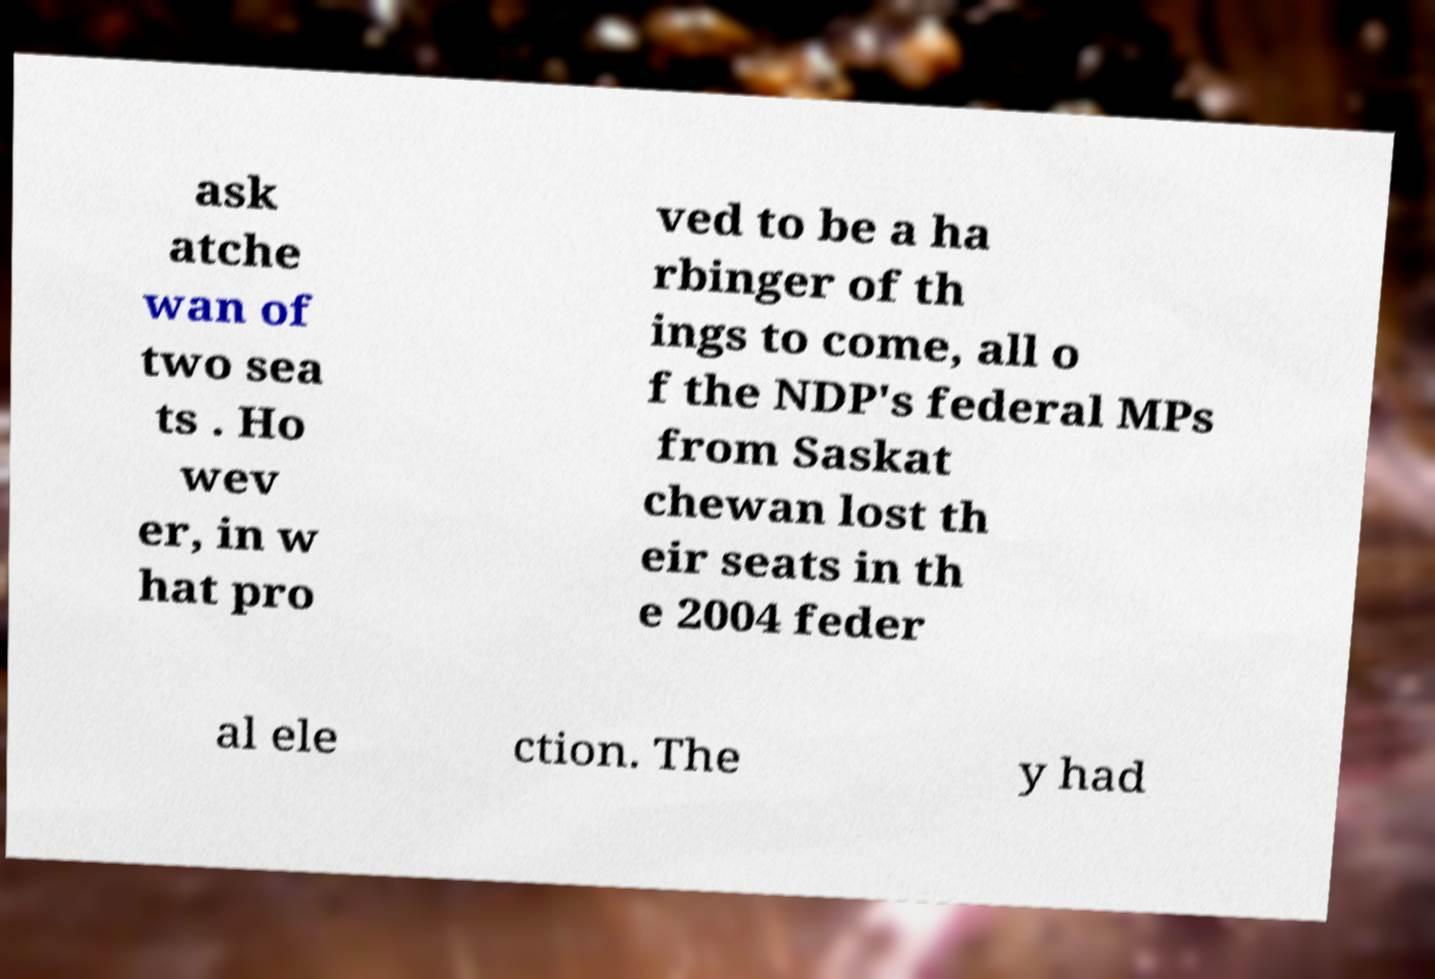Please identify and transcribe the text found in this image. ask atche wan of two sea ts . Ho wev er, in w hat pro ved to be a ha rbinger of th ings to come, all o f the NDP's federal MPs from Saskat chewan lost th eir seats in th e 2004 feder al ele ction. The y had 